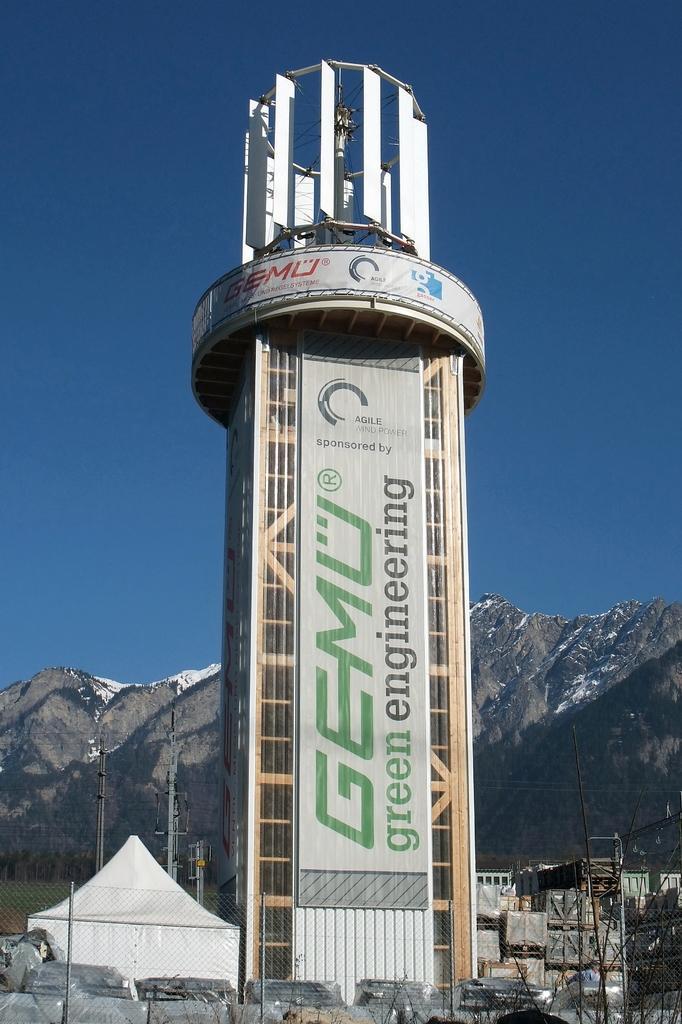How would you summarize this image in a sentence or two? In the picture we can see a tower building with some board and advertisement on it and near it, we can see some tent which is white in color and behind it, we can see some poles and in the background, we can see some hills with some part of snow on it and behind it we can see a sky which is blue in color. 